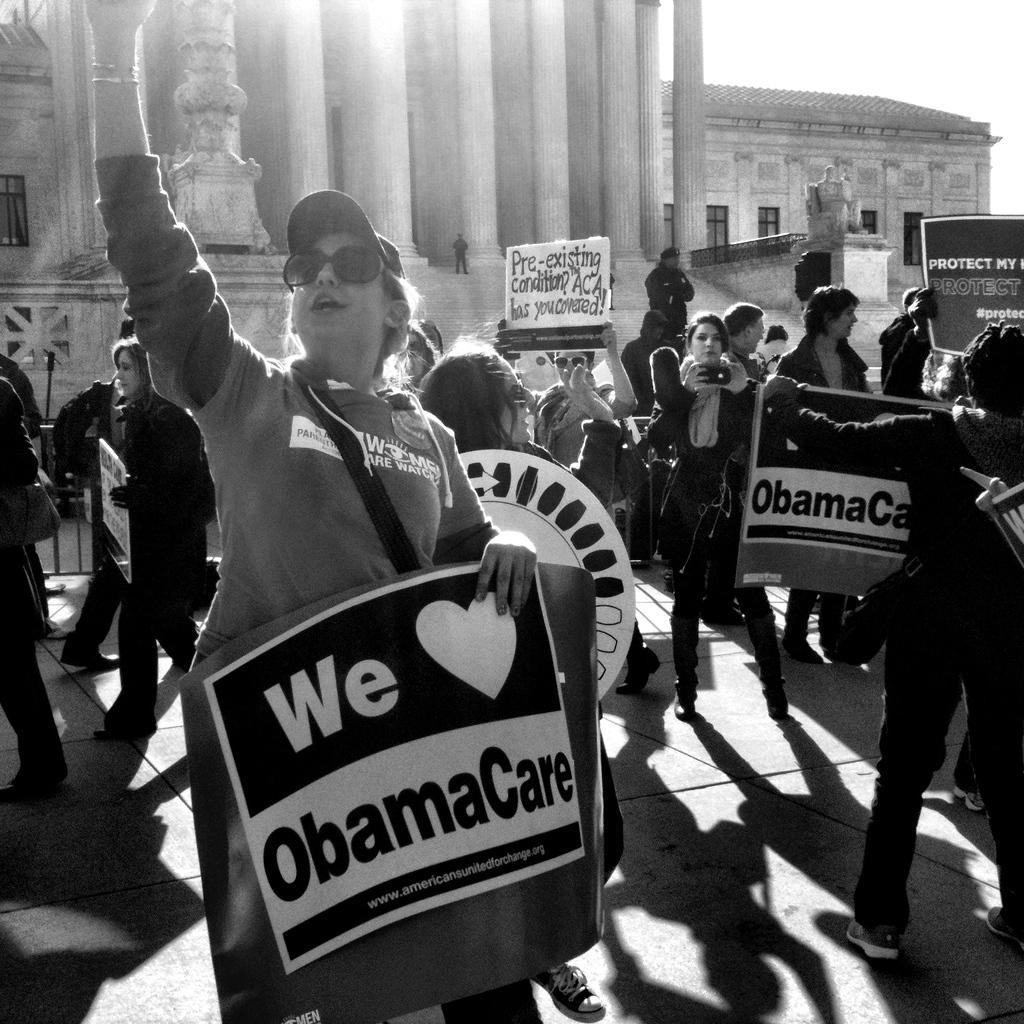What is the color scheme of the image? The image is black and white. What can be seen in the foreground of the image? There is a group of people standing in the image, and they are holding boards. What is visible in the background of the image? There are buildings in the background of the image, and they have windows and pillars. There is also a sculpture in the background. What type of current can be seen flowing through the sculpture in the image? There is no current visible in the image, as it is a black and white photograph. Additionally, there is no mention of a current or any electrical components in the provided facts. 